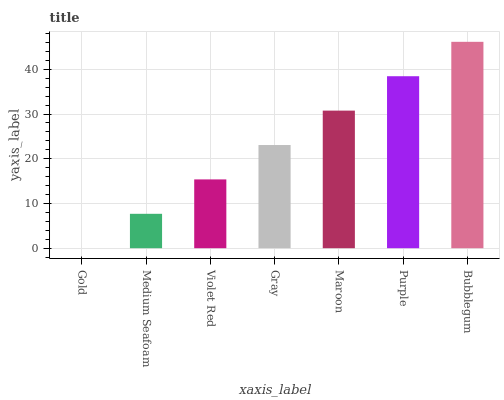Is Gold the minimum?
Answer yes or no. Yes. Is Bubblegum the maximum?
Answer yes or no. Yes. Is Medium Seafoam the minimum?
Answer yes or no. No. Is Medium Seafoam the maximum?
Answer yes or no. No. Is Medium Seafoam greater than Gold?
Answer yes or no. Yes. Is Gold less than Medium Seafoam?
Answer yes or no. Yes. Is Gold greater than Medium Seafoam?
Answer yes or no. No. Is Medium Seafoam less than Gold?
Answer yes or no. No. Is Gray the high median?
Answer yes or no. Yes. Is Gray the low median?
Answer yes or no. Yes. Is Violet Red the high median?
Answer yes or no. No. Is Medium Seafoam the low median?
Answer yes or no. No. 